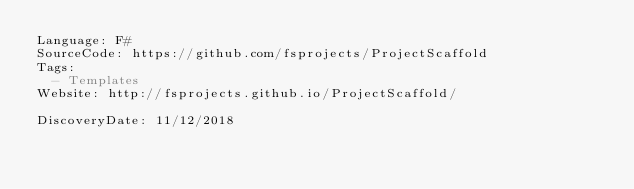<code> <loc_0><loc_0><loc_500><loc_500><_YAML_>Language: F#
SourceCode: https://github.com/fsprojects/ProjectScaffold
Tags:
  - Templates
Website: http://fsprojects.github.io/ProjectScaffold/

DiscoveryDate: 11/12/2018
</code> 